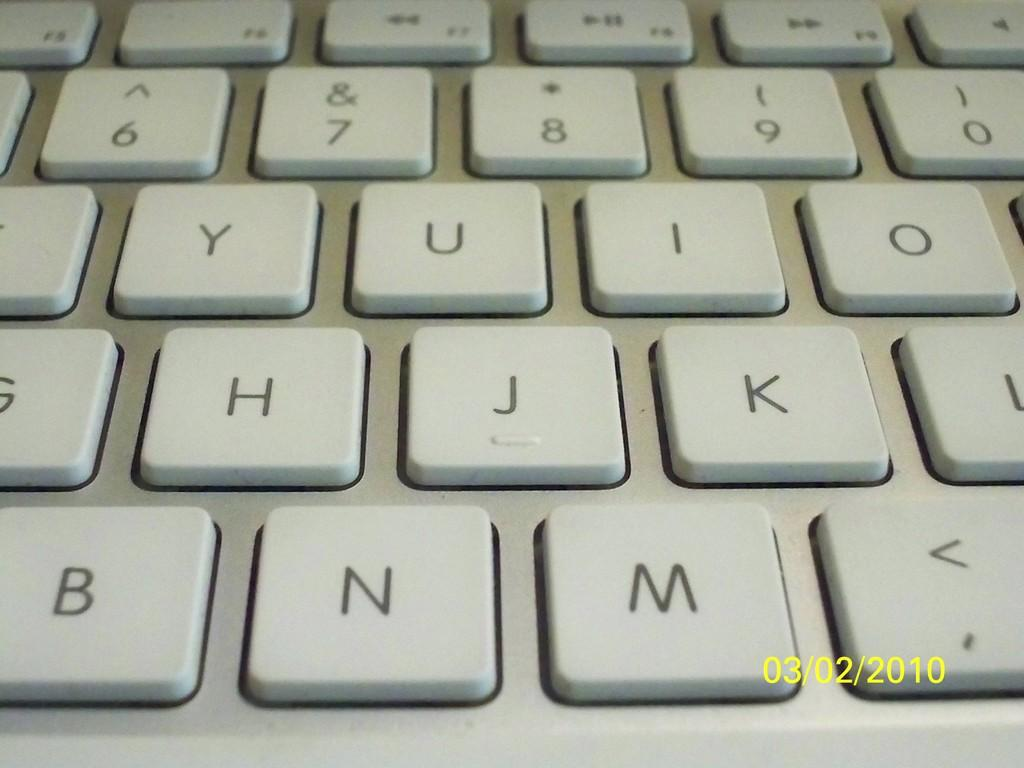<image>
Create a compact narrative representing the image presented. The letter N is to the left of the letter M. 